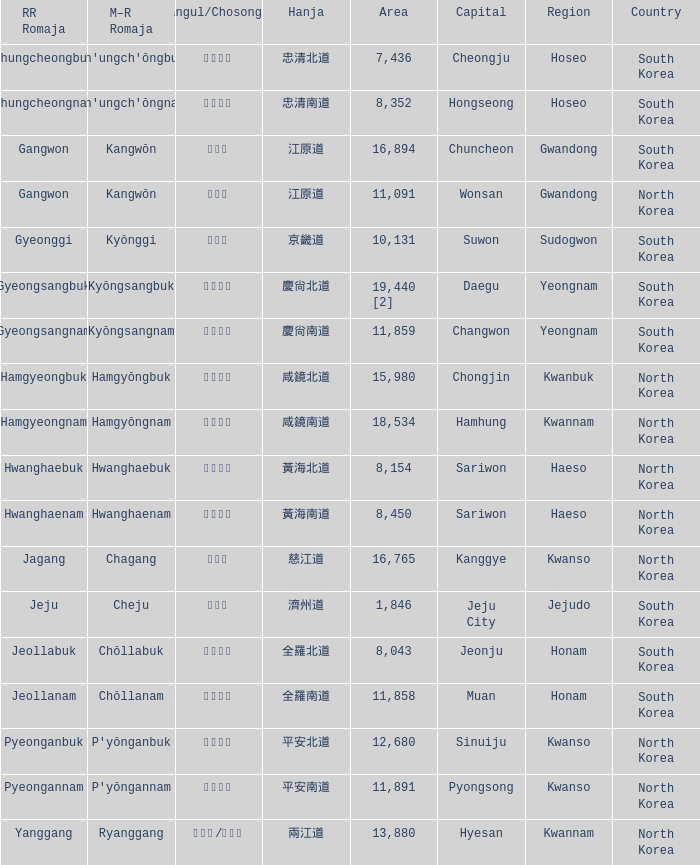Parse the full table. {'header': ['RR Romaja', 'M–R Romaja', 'Hangul/Chosongul', 'Hanja', 'Area', 'Capital', 'Region', 'Country'], 'rows': [['Chungcheongbuk', "Ch'ungch'ŏngbuk", '충청북도', '忠清北道', '7,436', 'Cheongju', 'Hoseo', 'South Korea'], ['Chungcheongnam', "Ch'ungch'ŏngnam", '충청남도', '忠清南道', '8,352', 'Hongseong', 'Hoseo', 'South Korea'], ['Gangwon', 'Kangwŏn', '강원도', '江原道', '16,894', 'Chuncheon', 'Gwandong', 'South Korea'], ['Gangwon', 'Kangwŏn', '강원도', '江原道', '11,091', 'Wonsan', 'Gwandong', 'North Korea'], ['Gyeonggi', 'Kyŏnggi', '경기도', '京畿道', '10,131', 'Suwon', 'Sudogwon', 'South Korea'], ['Gyeongsangbuk', 'Kyŏngsangbuk', '경상북도', '慶尙北道', '19,440 [2]', 'Daegu', 'Yeongnam', 'South Korea'], ['Gyeongsangnam', 'Kyŏngsangnam', '경상남도', '慶尙南道', '11,859', 'Changwon', 'Yeongnam', 'South Korea'], ['Hamgyeongbuk', 'Hamgyŏngbuk', '함경북도', '咸鏡北道', '15,980', 'Chongjin', 'Kwanbuk', 'North Korea'], ['Hamgyeongnam', 'Hamgyŏngnam', '함경남도', '咸鏡南道', '18,534', 'Hamhung', 'Kwannam', 'North Korea'], ['Hwanghaebuk', 'Hwanghaebuk', '황해북도', '黃海北道', '8,154', 'Sariwon', 'Haeso', 'North Korea'], ['Hwanghaenam', 'Hwanghaenam', '황해남도', '黃海南道', '8,450', 'Sariwon', 'Haeso', 'North Korea'], ['Jagang', 'Chagang', '자강도', '慈江道', '16,765', 'Kanggye', 'Kwanso', 'North Korea'], ['Jeju', 'Cheju', '제주도', '濟州道', '1,846', 'Jeju City', 'Jejudo', 'South Korea'], ['Jeollabuk', 'Chŏllabuk', '전라북도', '全羅北道', '8,043', 'Jeonju', 'Honam', 'South Korea'], ['Jeollanam', 'Chŏllanam', '전라남도', '全羅南道', '11,858', 'Muan', 'Honam', 'South Korea'], ['Pyeonganbuk', "P'yŏnganbuk", '평안북도', '平安北道', '12,680', 'Sinuiju', 'Kwanso', 'North Korea'], ['Pyeongannam', "P'yŏngannam", '평안남도', '平安南道', '11,891', 'Pyongsong', 'Kwanso', 'North Korea'], ['Yanggang', 'Ryanggang', '량강도/양강도', '兩江道', '13,880', 'Hyesan', 'Kwannam', 'North Korea']]} In which nation can a city with the hanja 平安北道 be found? North Korea. 